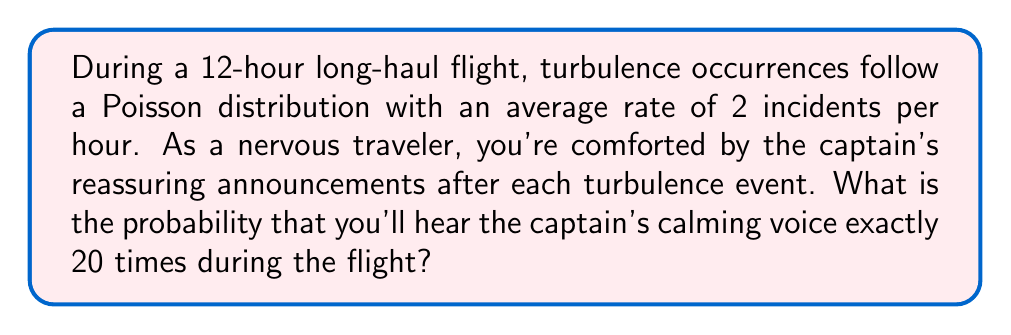Help me with this question. Let's approach this step-by-step:

1) First, we need to identify the parameters of our Poisson distribution:
   - The rate (λ) is 2 incidents per hour
   - The flight duration is 12 hours

2) We need to calculate the total rate for the entire flight:
   $$ \lambda_{total} = 2 \text{ incidents/hour} \times 12 \text{ hours} = 24 \text{ incidents} $$

3) Now, we can use the Poisson probability mass function to calculate the probability of exactly 20 occurrences:

   $$ P(X = k) = \frac{e^{-\lambda} \lambda^k}{k!} $$

   Where:
   - $e$ is Euler's number (approximately 2.71828)
   - $\lambda$ is our total rate (24)
   - $k$ is the number of occurrences we're interested in (20)

4) Let's substitute these values:

   $$ P(X = 20) = \frac{e^{-24} 24^{20}}{20!} $$

5) Now we can calculate this:
   
   $$ P(X = 20) = \frac{2.71828^{-24} \times 24^{20}}{2432902008176640000} $$

6) Using a calculator (as this is a complex calculation):

   $$ P(X = 20) \approx 0.0518 $$

This means there's approximately a 5.18% chance of experiencing exactly 20 turbulence events (and thus hearing 20 reassuring announcements from the captain) during the 12-hour flight.
Answer: 0.0518 or 5.18% 